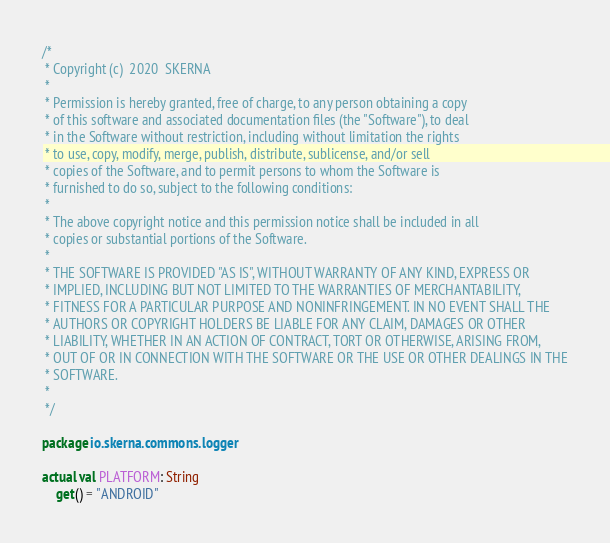<code> <loc_0><loc_0><loc_500><loc_500><_Kotlin_>/*
 * Copyright (c)  2020  SKERNA
 *
 * Permission is hereby granted, free of charge, to any person obtaining a copy
 * of this software and associated documentation files (the "Software"), to deal
 * in the Software without restriction, including without limitation the rights
 * to use, copy, modify, merge, publish, distribute, sublicense, and/or sell
 * copies of the Software, and to permit persons to whom the Software is
 * furnished to do so, subject to the following conditions:
 *
 * The above copyright notice and this permission notice shall be included in all
 * copies or substantial portions of the Software.
 *
 * THE SOFTWARE IS PROVIDED "AS IS", WITHOUT WARRANTY OF ANY KIND, EXPRESS OR
 * IMPLIED, INCLUDING BUT NOT LIMITED TO THE WARRANTIES OF MERCHANTABILITY,
 * FITNESS FOR A PARTICULAR PURPOSE AND NONINFRINGEMENT. IN NO EVENT SHALL THE
 * AUTHORS OR COPYRIGHT HOLDERS BE LIABLE FOR ANY CLAIM, DAMAGES OR OTHER
 * LIABILITY, WHETHER IN AN ACTION OF CONTRACT, TORT OR OTHERWISE, ARISING FROM,
 * OUT OF OR IN CONNECTION WITH THE SOFTWARE OR THE USE OR OTHER DEALINGS IN THE
 * SOFTWARE.
 *
 */

package io.skerna.commons.logger

actual val PLATFORM: String
    get() = "ANDROID"</code> 